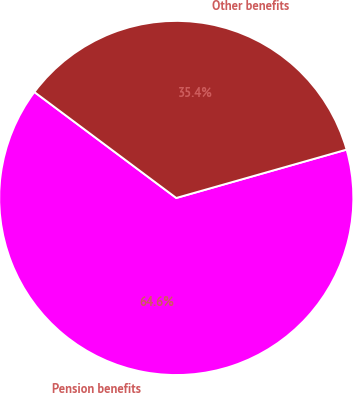Convert chart. <chart><loc_0><loc_0><loc_500><loc_500><pie_chart><fcel>Pension benefits<fcel>Other benefits<nl><fcel>64.61%<fcel>35.39%<nl></chart> 